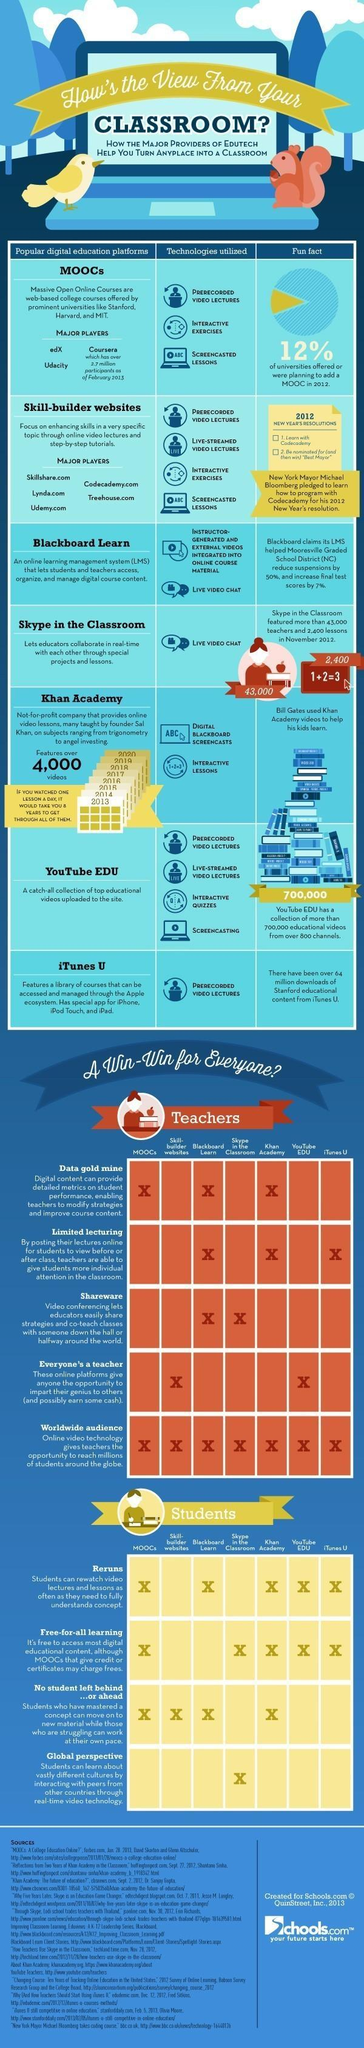Which digitals platforms offers opportunity for everyone to be a teacher ?
Answer the question with a short phrase. Skillbuilder websites, Youtube Edu Which popular digital platforms use live video chat technology? Blackboard Learn, Skype in the Classroom Which digital platform offers Data Gold Mine, Limited lecturing, or Audience? Khan Academy Which digital platform is listed in the fifth row? Khan Academy What common offering is provided by all digital education platform for all teachers? Worldwide Audience How many platforms let the students watch reruns of classes? 5 Which digital platforms do not provide free-for-all learning services? Skill builder websites, Blackboard Learn Which digital platform that provides global perspective to all students? Skype in the Classroom Which are popular digital education platforms? edX, Coursera, Udacity 